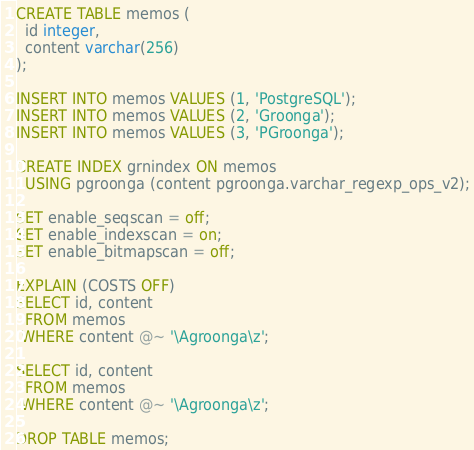<code> <loc_0><loc_0><loc_500><loc_500><_SQL_>CREATE TABLE memos (
  id integer,
  content varchar(256)
);

INSERT INTO memos VALUES (1, 'PostgreSQL');
INSERT INTO memos VALUES (2, 'Groonga');
INSERT INTO memos VALUES (3, 'PGroonga');

CREATE INDEX grnindex ON memos
  USING pgroonga (content pgroonga.varchar_regexp_ops_v2);

SET enable_seqscan = off;
SET enable_indexscan = on;
SET enable_bitmapscan = off;

EXPLAIN (COSTS OFF)
SELECT id, content
  FROM memos
 WHERE content @~ '\Agroonga\z';

SELECT id, content
  FROM memos
 WHERE content @~ '\Agroonga\z';

DROP TABLE memos;
</code> 